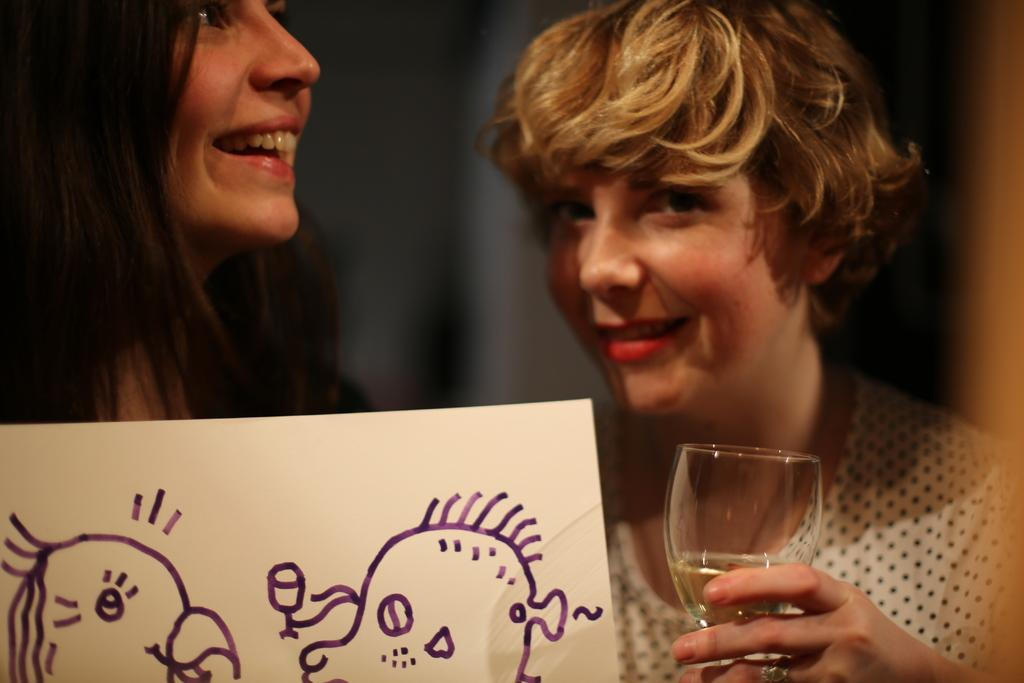How many people are in the image? There are two persons in the image. Can you describe one of the persons? One of the persons is a woman, and she is wearing a white dress. What is the woman holding in the image? The woman is holding a glass. What can be seen in front of the people in the image? There is a paper with a drawing in front of the people. What type of bubble can be seen floating near the woman in the image? There is no bubble present in the image; it only features two people and a paper with a drawing. What achievements has the pan accomplished, as seen in the image? There is no pan present in the image, and therefore no achievements can be attributed to it. 